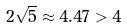Convert formula to latex. <formula><loc_0><loc_0><loc_500><loc_500>2 \sqrt { 5 } \approx 4 . 4 7 > 4</formula> 